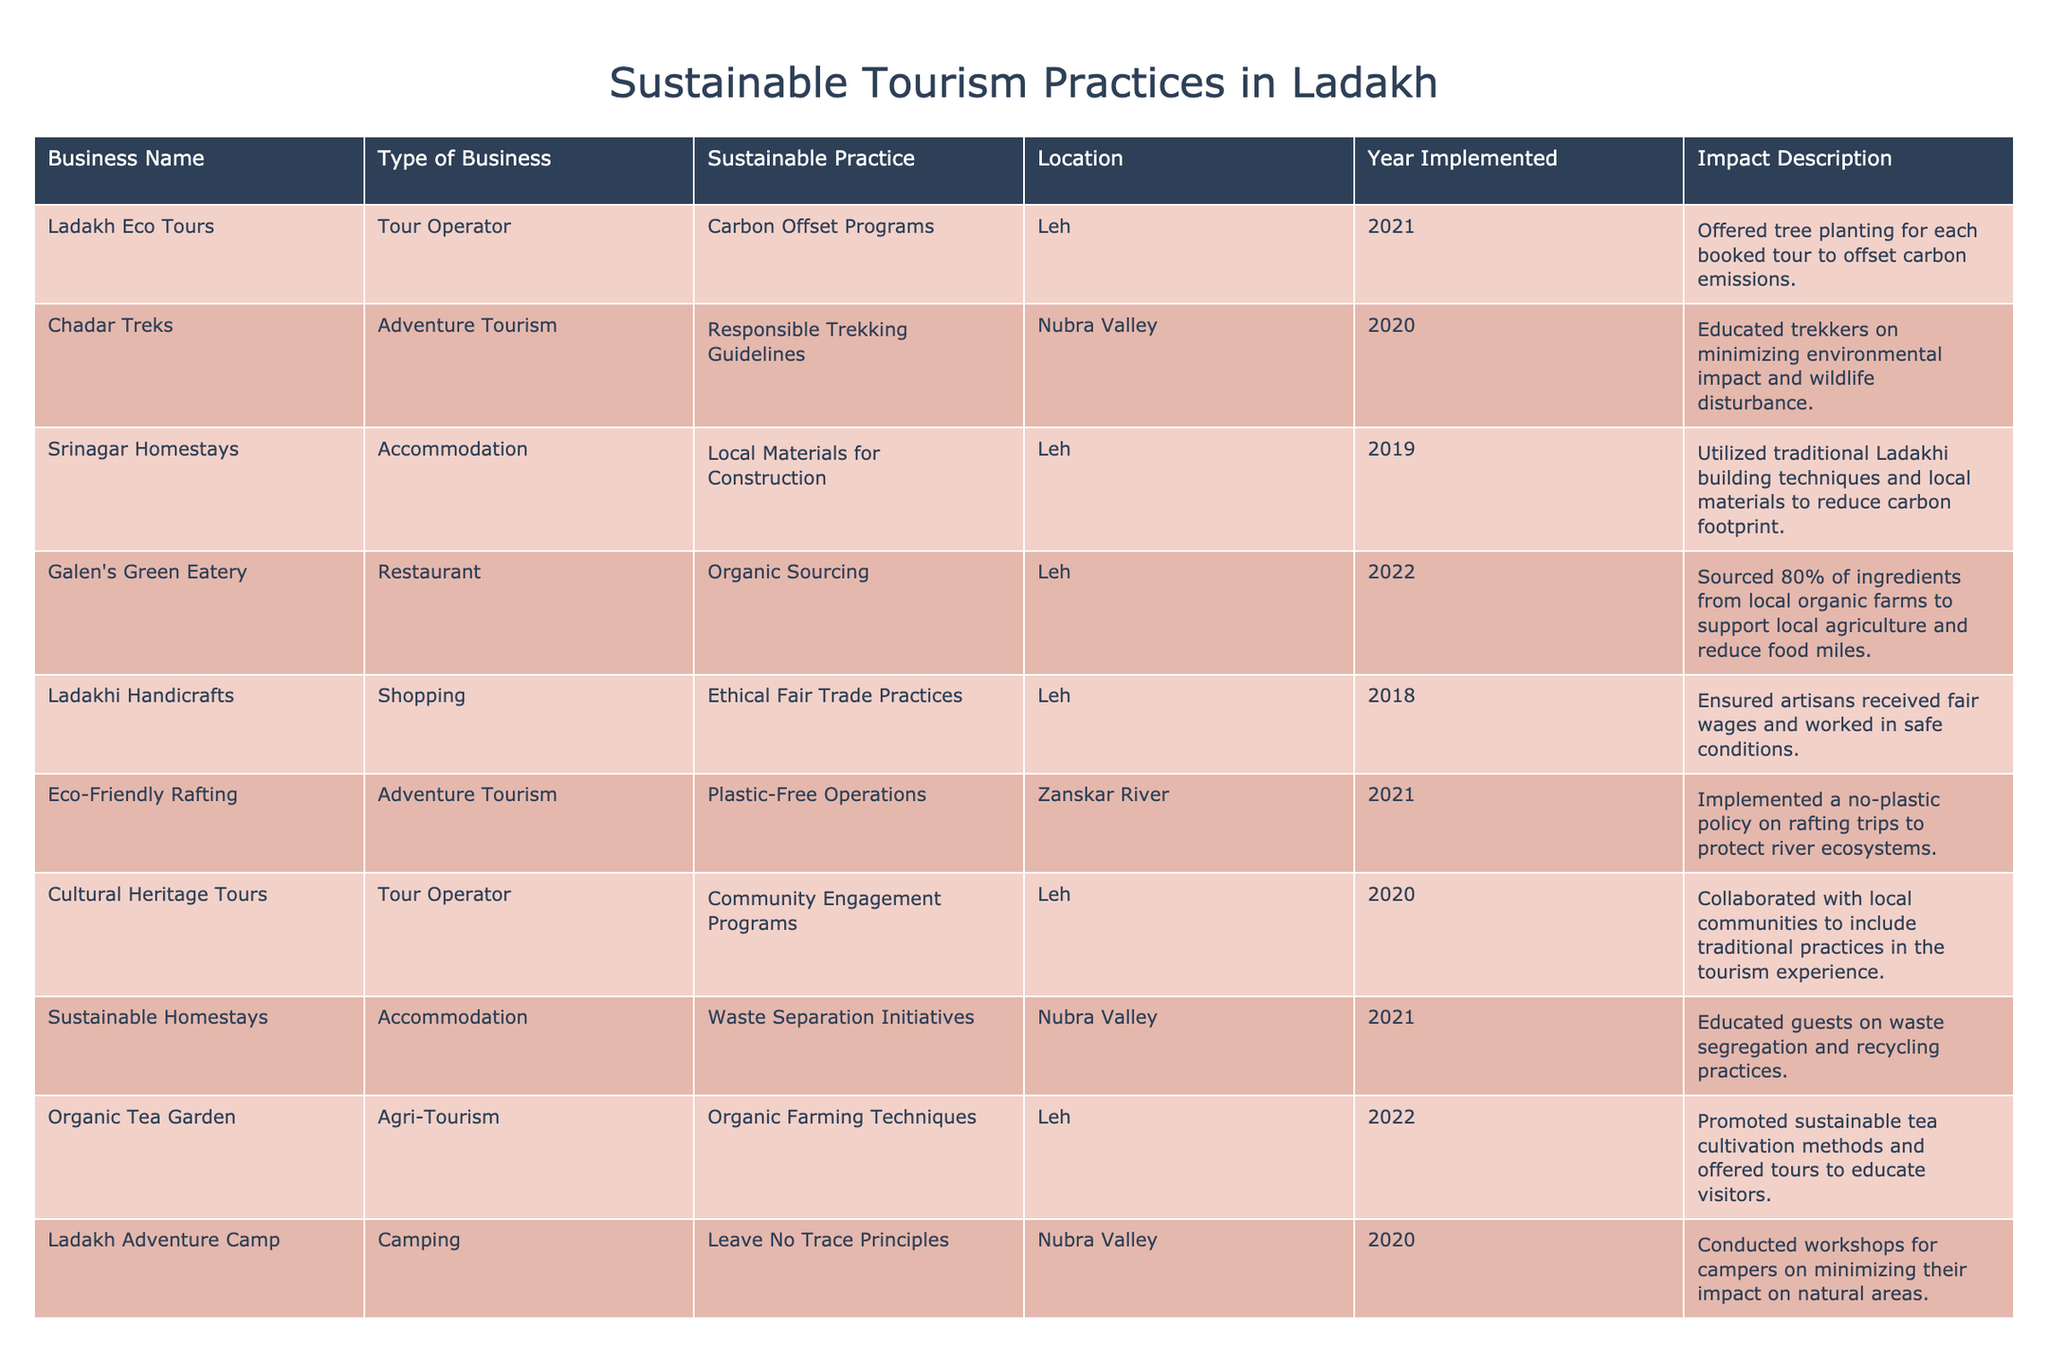What sustainable practice was implemented by Galen's Green Eatery? The table indicates that Galen's Green Eatery implemented organic sourcing as their sustainable practice.
Answer: Organic sourcing In which year did Ladakh Eco Tours begin their carbon offset programs? According to the table, Ladakh Eco Tours began their carbon offset programs in the year 2021.
Answer: 2021 What percentage of ingredients at Galen's Green Eatery comes from local organic farms? The table states that Galen's Green Eatery sources 80% of its ingredients from local organic farms.
Answer: 80% How many businesses implemented their sustainable practices in 2021? By counting the rows in the table for the year 2021, we find that there are three businesses: Ladakh Eco Tours, Eco-Friendly Rafting, and Sustainable Homestays. Thus, the total is three.
Answer: 3 Did any accommodation business utilize local materials for construction? Yes, the table shows that Srinagar Homestays utilized local materials for construction.
Answer: Yes Which type of sustainable practice focuses on waste management? The table shows that Sustainable Homestays focuses on waste separation initiatives, which is a type of waste management.
Answer: Waste separation initiatives Identify the two locations where sustainable accommodations are based. By examining the table, we can see that the two locations for sustainable accommodations are Leh (Srinagar Homestays) and Nubra Valley (Sustainable Homestays).
Answer: Leh and Nubra Valley What common feature is shared between Chadar Treks and Ladakh Adventure Camp? Both Chadar Treks and Ladakh Adventure Camp focus on responsible practices related to trekking and camping. Specifically, they emphasize minimizing environmental impact through responsible trekking guidelines and leave no trace principles, respectively.
Answer: Responsible practices in outdoor activities How many businesses implemented initiatives related to community engagement? Two businesses in the table implemented community engagement initiatives: Cultural Heritage Tours and the practices by Ladakhi Handicrafts.
Answer: 2 